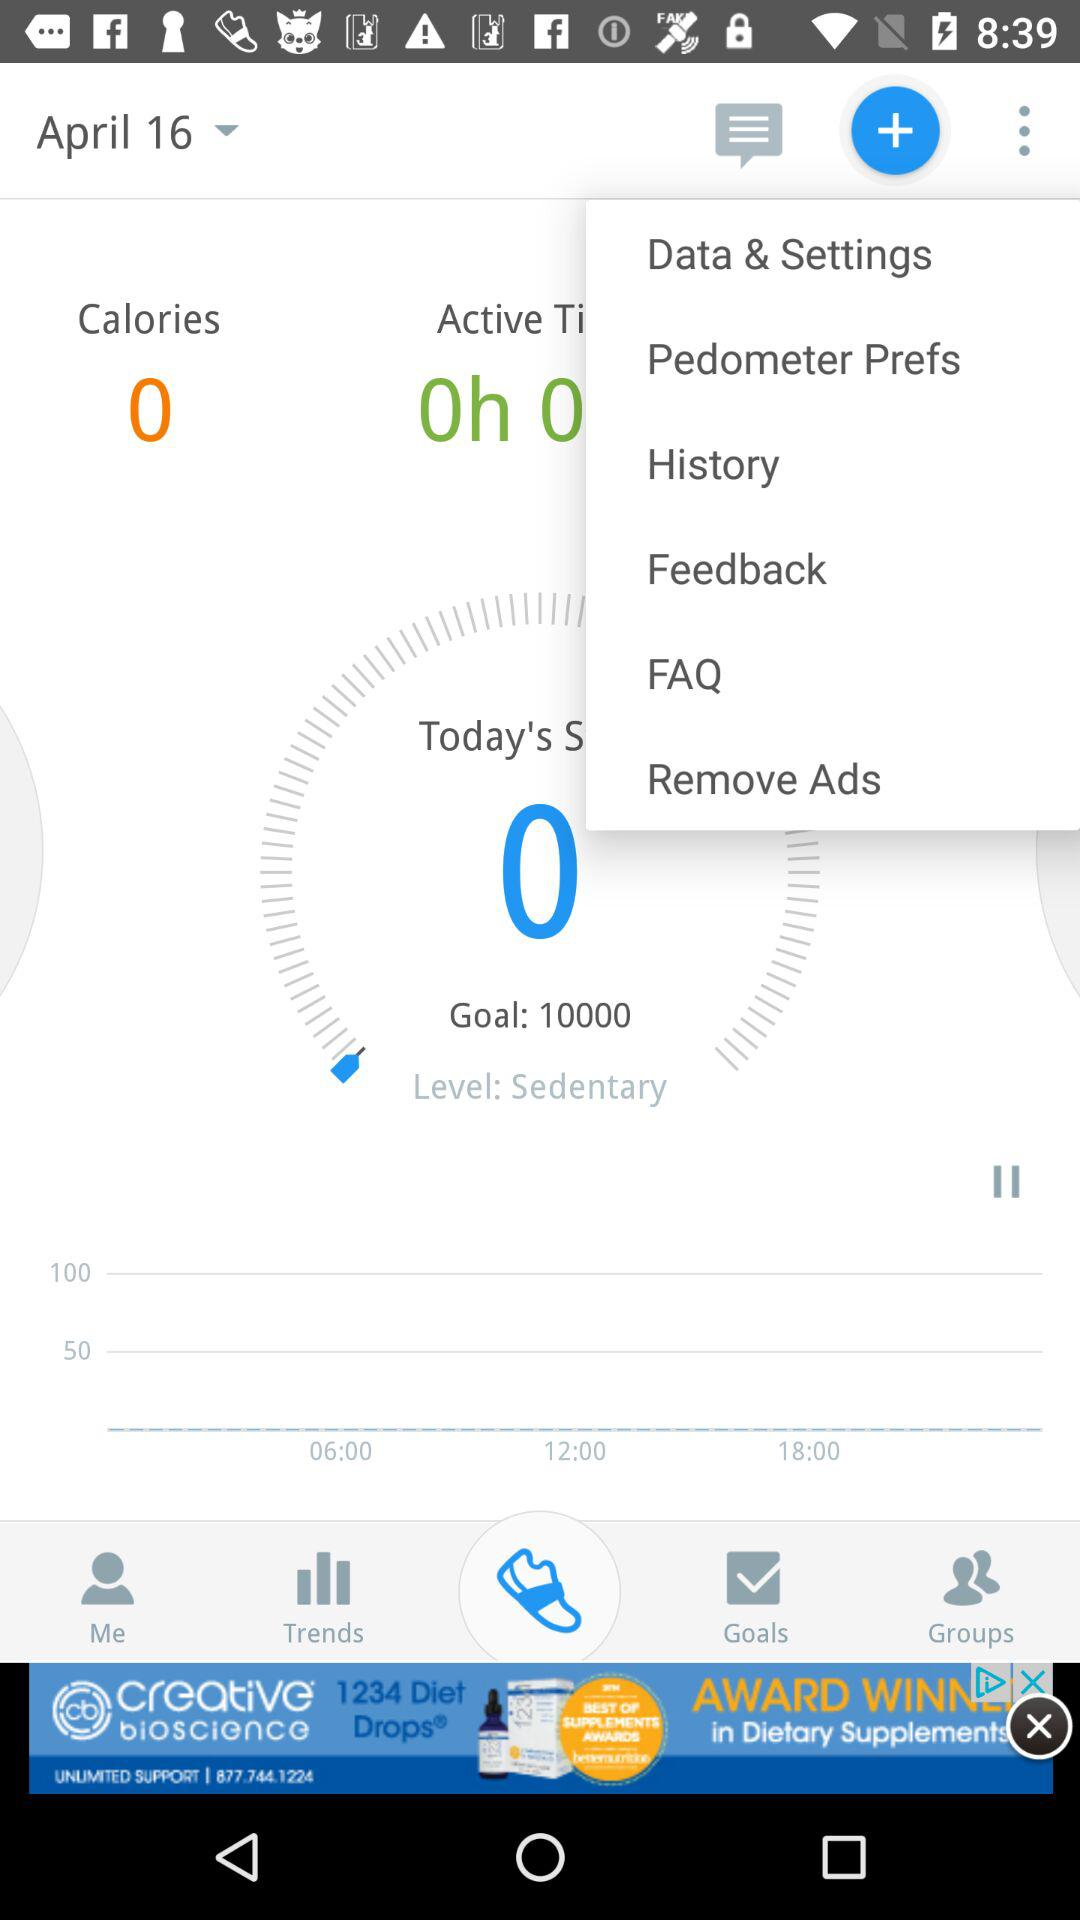How many calories are burned? There are 0 calories burned. 